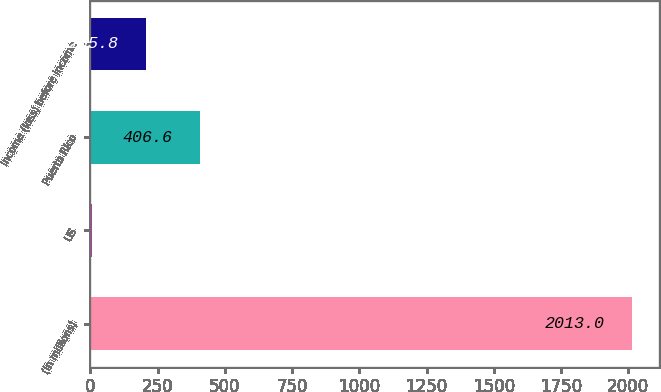Convert chart. <chart><loc_0><loc_0><loc_500><loc_500><bar_chart><fcel>(in millions)<fcel>US<fcel>Puerto Rico<fcel>Income (loss) before income<nl><fcel>2013<fcel>5<fcel>406.6<fcel>205.8<nl></chart> 